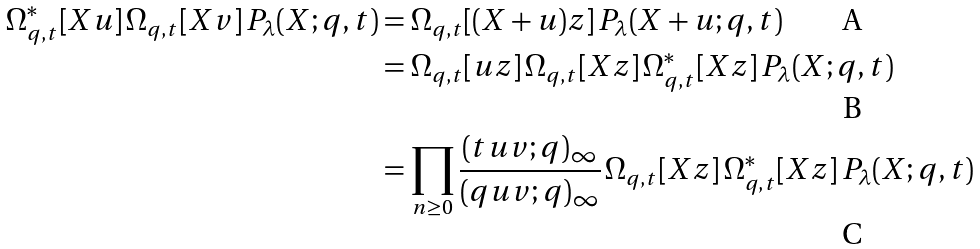<formula> <loc_0><loc_0><loc_500><loc_500>\Omega _ { q , t } ^ { * } [ X u ] \, \Omega _ { q , t } [ X v ] \, P _ { \lambda } ( X ; q , t ) & = \Omega _ { q , t } [ ( X + u ) z ] \, P _ { \lambda } ( X + u ; q , t ) \\ & = \Omega _ { q , t } [ u z ] \, \Omega _ { q , t } [ X z ] \, \Omega ^ { * } _ { q , t } [ X z ] \, P _ { \lambda } ( X ; q , t ) \\ & = \prod _ { n \geq 0 } \frac { ( t u v ; q ) _ { \infty } } { ( q u v ; q ) _ { \infty } } \, \Omega _ { q , t } [ X z ] \, \Omega ^ { * } _ { q , t } [ X z ] \, P _ { \lambda } ( X ; q , t )</formula> 